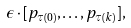<formula> <loc_0><loc_0><loc_500><loc_500>\epsilon \cdot [ p _ { \tau ( 0 ) } , \dots , p _ { \tau ( k ) } ] ,</formula> 